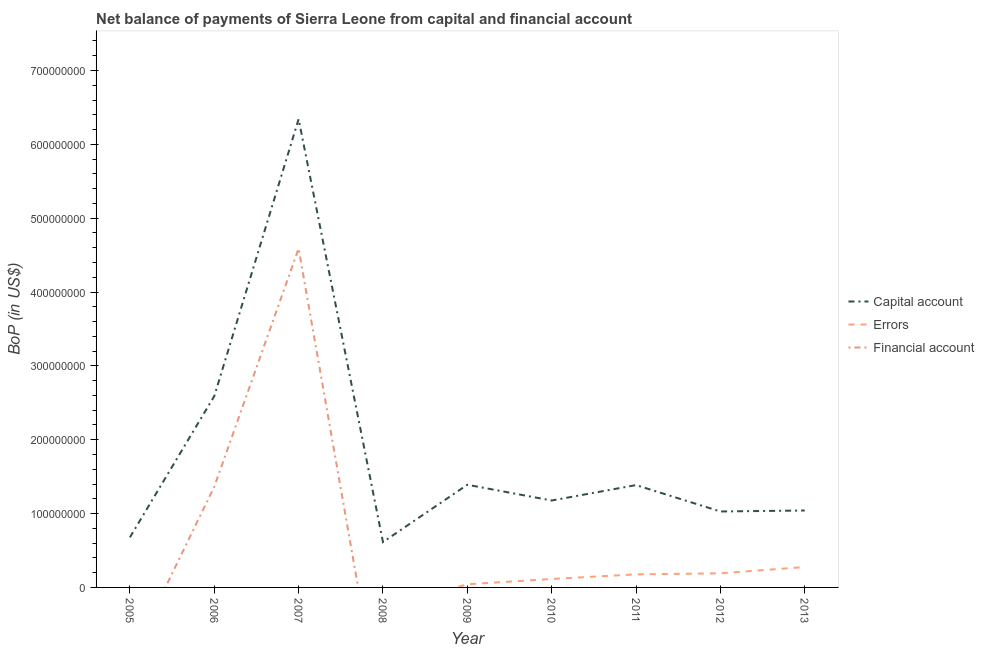What is the amount of net capital account in 2010?
Give a very brief answer. 1.18e+08. Across all years, what is the maximum amount of errors?
Offer a very short reply. 2.76e+07. Across all years, what is the minimum amount of financial account?
Your answer should be compact. 0. What is the total amount of errors in the graph?
Provide a succinct answer. 8.02e+07. What is the difference between the amount of errors in 2009 and that in 2013?
Offer a very short reply. -2.34e+07. What is the difference between the amount of errors in 2010 and the amount of net capital account in 2012?
Provide a short and direct response. -9.14e+07. What is the average amount of financial account per year?
Keep it short and to the point. 6.61e+07. In the year 2007, what is the difference between the amount of financial account and amount of net capital account?
Provide a succinct answer. -1.75e+08. In how many years, is the amount of net capital account greater than 280000000 US$?
Give a very brief answer. 1. What is the ratio of the amount of net capital account in 2008 to that in 2011?
Your answer should be very brief. 0.44. What is the difference between the highest and the second highest amount of errors?
Make the answer very short. 8.55e+06. What is the difference between the highest and the lowest amount of errors?
Provide a succinct answer. 2.76e+07. Is the sum of the amount of net capital account in 2008 and 2011 greater than the maximum amount of errors across all years?
Your answer should be very brief. Yes. Is it the case that in every year, the sum of the amount of net capital account and amount of errors is greater than the amount of financial account?
Offer a terse response. Yes. Does the amount of net capital account monotonically increase over the years?
Provide a succinct answer. No. How many years are there in the graph?
Your answer should be compact. 9. What is the difference between two consecutive major ticks on the Y-axis?
Provide a short and direct response. 1.00e+08. Are the values on the major ticks of Y-axis written in scientific E-notation?
Keep it short and to the point. No. Does the graph contain grids?
Make the answer very short. No. Where does the legend appear in the graph?
Offer a terse response. Center right. What is the title of the graph?
Your response must be concise. Net balance of payments of Sierra Leone from capital and financial account. Does "Natural gas sources" appear as one of the legend labels in the graph?
Make the answer very short. No. What is the label or title of the Y-axis?
Offer a terse response. BoP (in US$). What is the BoP (in US$) of Capital account in 2005?
Your response must be concise. 6.78e+07. What is the BoP (in US$) in Capital account in 2006?
Ensure brevity in your answer.  2.59e+08. What is the BoP (in US$) of Financial account in 2006?
Give a very brief answer. 1.36e+08. What is the BoP (in US$) of Capital account in 2007?
Your answer should be very brief. 6.34e+08. What is the BoP (in US$) of Errors in 2007?
Provide a succinct answer. 0. What is the BoP (in US$) of Financial account in 2007?
Keep it short and to the point. 4.59e+08. What is the BoP (in US$) of Capital account in 2008?
Keep it short and to the point. 6.14e+07. What is the BoP (in US$) of Errors in 2008?
Ensure brevity in your answer.  0. What is the BoP (in US$) of Capital account in 2009?
Offer a very short reply. 1.39e+08. What is the BoP (in US$) in Errors in 2009?
Keep it short and to the point. 4.23e+06. What is the BoP (in US$) of Capital account in 2010?
Offer a terse response. 1.18e+08. What is the BoP (in US$) in Errors in 2010?
Your answer should be compact. 1.15e+07. What is the BoP (in US$) of Capital account in 2011?
Provide a succinct answer. 1.39e+08. What is the BoP (in US$) of Errors in 2011?
Your answer should be compact. 1.77e+07. What is the BoP (in US$) of Capital account in 2012?
Provide a succinct answer. 1.03e+08. What is the BoP (in US$) of Errors in 2012?
Provide a succinct answer. 1.91e+07. What is the BoP (in US$) in Capital account in 2013?
Your response must be concise. 1.04e+08. What is the BoP (in US$) of Errors in 2013?
Offer a very short reply. 2.76e+07. Across all years, what is the maximum BoP (in US$) of Capital account?
Provide a succinct answer. 6.34e+08. Across all years, what is the maximum BoP (in US$) of Errors?
Offer a terse response. 2.76e+07. Across all years, what is the maximum BoP (in US$) of Financial account?
Your response must be concise. 4.59e+08. Across all years, what is the minimum BoP (in US$) of Capital account?
Provide a short and direct response. 6.14e+07. What is the total BoP (in US$) in Capital account in the graph?
Provide a short and direct response. 1.62e+09. What is the total BoP (in US$) in Errors in the graph?
Offer a very short reply. 8.02e+07. What is the total BoP (in US$) of Financial account in the graph?
Make the answer very short. 5.95e+08. What is the difference between the BoP (in US$) of Capital account in 2005 and that in 2006?
Offer a very short reply. -1.91e+08. What is the difference between the BoP (in US$) of Capital account in 2005 and that in 2007?
Your answer should be very brief. -5.66e+08. What is the difference between the BoP (in US$) of Capital account in 2005 and that in 2008?
Offer a terse response. 6.38e+06. What is the difference between the BoP (in US$) in Capital account in 2005 and that in 2009?
Ensure brevity in your answer.  -7.12e+07. What is the difference between the BoP (in US$) of Capital account in 2005 and that in 2010?
Your answer should be very brief. -4.99e+07. What is the difference between the BoP (in US$) of Capital account in 2005 and that in 2011?
Your answer should be compact. -7.08e+07. What is the difference between the BoP (in US$) in Capital account in 2005 and that in 2012?
Ensure brevity in your answer.  -3.51e+07. What is the difference between the BoP (in US$) of Capital account in 2005 and that in 2013?
Offer a very short reply. -3.64e+07. What is the difference between the BoP (in US$) in Capital account in 2006 and that in 2007?
Provide a short and direct response. -3.75e+08. What is the difference between the BoP (in US$) of Financial account in 2006 and that in 2007?
Ensure brevity in your answer.  -3.23e+08. What is the difference between the BoP (in US$) in Capital account in 2006 and that in 2008?
Make the answer very short. 1.98e+08. What is the difference between the BoP (in US$) in Capital account in 2006 and that in 2009?
Keep it short and to the point. 1.20e+08. What is the difference between the BoP (in US$) of Capital account in 2006 and that in 2010?
Provide a short and direct response. 1.41e+08. What is the difference between the BoP (in US$) of Capital account in 2006 and that in 2011?
Make the answer very short. 1.20e+08. What is the difference between the BoP (in US$) of Capital account in 2006 and that in 2012?
Your answer should be compact. 1.56e+08. What is the difference between the BoP (in US$) in Capital account in 2006 and that in 2013?
Your response must be concise. 1.55e+08. What is the difference between the BoP (in US$) of Capital account in 2007 and that in 2008?
Keep it short and to the point. 5.73e+08. What is the difference between the BoP (in US$) of Capital account in 2007 and that in 2009?
Your answer should be compact. 4.95e+08. What is the difference between the BoP (in US$) in Capital account in 2007 and that in 2010?
Make the answer very short. 5.16e+08. What is the difference between the BoP (in US$) of Capital account in 2007 and that in 2011?
Your answer should be very brief. 4.96e+08. What is the difference between the BoP (in US$) of Capital account in 2007 and that in 2012?
Give a very brief answer. 5.31e+08. What is the difference between the BoP (in US$) of Capital account in 2007 and that in 2013?
Offer a very short reply. 5.30e+08. What is the difference between the BoP (in US$) of Capital account in 2008 and that in 2009?
Offer a very short reply. -7.76e+07. What is the difference between the BoP (in US$) of Capital account in 2008 and that in 2010?
Your answer should be very brief. -5.63e+07. What is the difference between the BoP (in US$) in Capital account in 2008 and that in 2011?
Give a very brief answer. -7.72e+07. What is the difference between the BoP (in US$) in Capital account in 2008 and that in 2012?
Keep it short and to the point. -4.14e+07. What is the difference between the BoP (in US$) of Capital account in 2008 and that in 2013?
Provide a short and direct response. -4.27e+07. What is the difference between the BoP (in US$) of Capital account in 2009 and that in 2010?
Offer a very short reply. 2.13e+07. What is the difference between the BoP (in US$) of Errors in 2009 and that in 2010?
Keep it short and to the point. -7.24e+06. What is the difference between the BoP (in US$) of Capital account in 2009 and that in 2011?
Your answer should be very brief. 4.53e+05. What is the difference between the BoP (in US$) in Errors in 2009 and that in 2011?
Provide a succinct answer. -1.35e+07. What is the difference between the BoP (in US$) of Capital account in 2009 and that in 2012?
Offer a very short reply. 3.62e+07. What is the difference between the BoP (in US$) of Errors in 2009 and that in 2012?
Give a very brief answer. -1.49e+07. What is the difference between the BoP (in US$) in Capital account in 2009 and that in 2013?
Offer a terse response. 3.49e+07. What is the difference between the BoP (in US$) of Errors in 2009 and that in 2013?
Provide a short and direct response. -2.34e+07. What is the difference between the BoP (in US$) of Capital account in 2010 and that in 2011?
Your answer should be compact. -2.09e+07. What is the difference between the BoP (in US$) of Errors in 2010 and that in 2011?
Ensure brevity in your answer.  -6.23e+06. What is the difference between the BoP (in US$) of Capital account in 2010 and that in 2012?
Your answer should be compact. 1.48e+07. What is the difference between the BoP (in US$) in Errors in 2010 and that in 2012?
Offer a very short reply. -7.62e+06. What is the difference between the BoP (in US$) of Capital account in 2010 and that in 2013?
Your answer should be compact. 1.35e+07. What is the difference between the BoP (in US$) in Errors in 2010 and that in 2013?
Your answer should be very brief. -1.62e+07. What is the difference between the BoP (in US$) in Capital account in 2011 and that in 2012?
Offer a very short reply. 3.57e+07. What is the difference between the BoP (in US$) in Errors in 2011 and that in 2012?
Give a very brief answer. -1.39e+06. What is the difference between the BoP (in US$) of Capital account in 2011 and that in 2013?
Your answer should be compact. 3.44e+07. What is the difference between the BoP (in US$) in Errors in 2011 and that in 2013?
Your answer should be very brief. -9.94e+06. What is the difference between the BoP (in US$) of Capital account in 2012 and that in 2013?
Give a very brief answer. -1.31e+06. What is the difference between the BoP (in US$) in Errors in 2012 and that in 2013?
Give a very brief answer. -8.55e+06. What is the difference between the BoP (in US$) in Capital account in 2005 and the BoP (in US$) in Financial account in 2006?
Make the answer very short. -6.86e+07. What is the difference between the BoP (in US$) in Capital account in 2005 and the BoP (in US$) in Financial account in 2007?
Offer a very short reply. -3.91e+08. What is the difference between the BoP (in US$) of Capital account in 2005 and the BoP (in US$) of Errors in 2009?
Your answer should be compact. 6.36e+07. What is the difference between the BoP (in US$) of Capital account in 2005 and the BoP (in US$) of Errors in 2010?
Your response must be concise. 5.63e+07. What is the difference between the BoP (in US$) of Capital account in 2005 and the BoP (in US$) of Errors in 2011?
Offer a very short reply. 5.01e+07. What is the difference between the BoP (in US$) of Capital account in 2005 and the BoP (in US$) of Errors in 2012?
Provide a succinct answer. 4.87e+07. What is the difference between the BoP (in US$) of Capital account in 2005 and the BoP (in US$) of Errors in 2013?
Provide a short and direct response. 4.02e+07. What is the difference between the BoP (in US$) in Capital account in 2006 and the BoP (in US$) in Financial account in 2007?
Give a very brief answer. -2.00e+08. What is the difference between the BoP (in US$) in Capital account in 2006 and the BoP (in US$) in Errors in 2009?
Your response must be concise. 2.55e+08. What is the difference between the BoP (in US$) of Capital account in 2006 and the BoP (in US$) of Errors in 2010?
Keep it short and to the point. 2.48e+08. What is the difference between the BoP (in US$) in Capital account in 2006 and the BoP (in US$) in Errors in 2011?
Your response must be concise. 2.41e+08. What is the difference between the BoP (in US$) in Capital account in 2006 and the BoP (in US$) in Errors in 2012?
Make the answer very short. 2.40e+08. What is the difference between the BoP (in US$) in Capital account in 2006 and the BoP (in US$) in Errors in 2013?
Offer a very short reply. 2.31e+08. What is the difference between the BoP (in US$) in Capital account in 2007 and the BoP (in US$) in Errors in 2009?
Provide a short and direct response. 6.30e+08. What is the difference between the BoP (in US$) in Capital account in 2007 and the BoP (in US$) in Errors in 2010?
Your response must be concise. 6.23e+08. What is the difference between the BoP (in US$) in Capital account in 2007 and the BoP (in US$) in Errors in 2011?
Offer a very short reply. 6.16e+08. What is the difference between the BoP (in US$) of Capital account in 2007 and the BoP (in US$) of Errors in 2012?
Provide a short and direct response. 6.15e+08. What is the difference between the BoP (in US$) in Capital account in 2007 and the BoP (in US$) in Errors in 2013?
Keep it short and to the point. 6.07e+08. What is the difference between the BoP (in US$) in Capital account in 2008 and the BoP (in US$) in Errors in 2009?
Provide a short and direct response. 5.72e+07. What is the difference between the BoP (in US$) in Capital account in 2008 and the BoP (in US$) in Errors in 2010?
Offer a terse response. 5.00e+07. What is the difference between the BoP (in US$) in Capital account in 2008 and the BoP (in US$) in Errors in 2011?
Your response must be concise. 4.37e+07. What is the difference between the BoP (in US$) of Capital account in 2008 and the BoP (in US$) of Errors in 2012?
Your response must be concise. 4.23e+07. What is the difference between the BoP (in US$) in Capital account in 2008 and the BoP (in US$) in Errors in 2013?
Offer a terse response. 3.38e+07. What is the difference between the BoP (in US$) of Capital account in 2009 and the BoP (in US$) of Errors in 2010?
Ensure brevity in your answer.  1.28e+08. What is the difference between the BoP (in US$) in Capital account in 2009 and the BoP (in US$) in Errors in 2011?
Keep it short and to the point. 1.21e+08. What is the difference between the BoP (in US$) in Capital account in 2009 and the BoP (in US$) in Errors in 2012?
Your answer should be very brief. 1.20e+08. What is the difference between the BoP (in US$) in Capital account in 2009 and the BoP (in US$) in Errors in 2013?
Keep it short and to the point. 1.11e+08. What is the difference between the BoP (in US$) of Capital account in 2010 and the BoP (in US$) of Errors in 2011?
Offer a terse response. 1.00e+08. What is the difference between the BoP (in US$) in Capital account in 2010 and the BoP (in US$) in Errors in 2012?
Keep it short and to the point. 9.86e+07. What is the difference between the BoP (in US$) of Capital account in 2010 and the BoP (in US$) of Errors in 2013?
Provide a short and direct response. 9.01e+07. What is the difference between the BoP (in US$) of Capital account in 2011 and the BoP (in US$) of Errors in 2012?
Ensure brevity in your answer.  1.19e+08. What is the difference between the BoP (in US$) in Capital account in 2011 and the BoP (in US$) in Errors in 2013?
Ensure brevity in your answer.  1.11e+08. What is the difference between the BoP (in US$) of Capital account in 2012 and the BoP (in US$) of Errors in 2013?
Keep it short and to the point. 7.52e+07. What is the average BoP (in US$) in Capital account per year?
Keep it short and to the point. 1.81e+08. What is the average BoP (in US$) of Errors per year?
Offer a very short reply. 8.91e+06. What is the average BoP (in US$) of Financial account per year?
Offer a terse response. 6.61e+07. In the year 2006, what is the difference between the BoP (in US$) in Capital account and BoP (in US$) in Financial account?
Ensure brevity in your answer.  1.23e+08. In the year 2007, what is the difference between the BoP (in US$) of Capital account and BoP (in US$) of Financial account?
Your response must be concise. 1.75e+08. In the year 2009, what is the difference between the BoP (in US$) of Capital account and BoP (in US$) of Errors?
Your answer should be compact. 1.35e+08. In the year 2010, what is the difference between the BoP (in US$) in Capital account and BoP (in US$) in Errors?
Your response must be concise. 1.06e+08. In the year 2011, what is the difference between the BoP (in US$) in Capital account and BoP (in US$) in Errors?
Your answer should be very brief. 1.21e+08. In the year 2012, what is the difference between the BoP (in US$) in Capital account and BoP (in US$) in Errors?
Keep it short and to the point. 8.38e+07. In the year 2013, what is the difference between the BoP (in US$) in Capital account and BoP (in US$) in Errors?
Provide a short and direct response. 7.65e+07. What is the ratio of the BoP (in US$) in Capital account in 2005 to that in 2006?
Provide a succinct answer. 0.26. What is the ratio of the BoP (in US$) in Capital account in 2005 to that in 2007?
Your response must be concise. 0.11. What is the ratio of the BoP (in US$) of Capital account in 2005 to that in 2008?
Offer a terse response. 1.1. What is the ratio of the BoP (in US$) in Capital account in 2005 to that in 2009?
Provide a short and direct response. 0.49. What is the ratio of the BoP (in US$) in Capital account in 2005 to that in 2010?
Give a very brief answer. 0.58. What is the ratio of the BoP (in US$) of Capital account in 2005 to that in 2011?
Your answer should be very brief. 0.49. What is the ratio of the BoP (in US$) of Capital account in 2005 to that in 2012?
Ensure brevity in your answer.  0.66. What is the ratio of the BoP (in US$) in Capital account in 2005 to that in 2013?
Ensure brevity in your answer.  0.65. What is the ratio of the BoP (in US$) in Capital account in 2006 to that in 2007?
Give a very brief answer. 0.41. What is the ratio of the BoP (in US$) of Financial account in 2006 to that in 2007?
Offer a terse response. 0.3. What is the ratio of the BoP (in US$) in Capital account in 2006 to that in 2008?
Give a very brief answer. 4.22. What is the ratio of the BoP (in US$) in Capital account in 2006 to that in 2009?
Your answer should be very brief. 1.86. What is the ratio of the BoP (in US$) of Capital account in 2006 to that in 2010?
Provide a short and direct response. 2.2. What is the ratio of the BoP (in US$) of Capital account in 2006 to that in 2011?
Ensure brevity in your answer.  1.87. What is the ratio of the BoP (in US$) in Capital account in 2006 to that in 2012?
Your response must be concise. 2.52. What is the ratio of the BoP (in US$) in Capital account in 2006 to that in 2013?
Make the answer very short. 2.49. What is the ratio of the BoP (in US$) of Capital account in 2007 to that in 2008?
Offer a very short reply. 10.32. What is the ratio of the BoP (in US$) of Capital account in 2007 to that in 2009?
Offer a very short reply. 4.56. What is the ratio of the BoP (in US$) in Capital account in 2007 to that in 2010?
Ensure brevity in your answer.  5.39. What is the ratio of the BoP (in US$) in Capital account in 2007 to that in 2011?
Your answer should be very brief. 4.58. What is the ratio of the BoP (in US$) of Capital account in 2007 to that in 2012?
Keep it short and to the point. 6.17. What is the ratio of the BoP (in US$) of Capital account in 2007 to that in 2013?
Your answer should be very brief. 6.09. What is the ratio of the BoP (in US$) in Capital account in 2008 to that in 2009?
Offer a terse response. 0.44. What is the ratio of the BoP (in US$) in Capital account in 2008 to that in 2010?
Give a very brief answer. 0.52. What is the ratio of the BoP (in US$) in Capital account in 2008 to that in 2011?
Give a very brief answer. 0.44. What is the ratio of the BoP (in US$) in Capital account in 2008 to that in 2012?
Provide a succinct answer. 0.6. What is the ratio of the BoP (in US$) in Capital account in 2008 to that in 2013?
Offer a terse response. 0.59. What is the ratio of the BoP (in US$) in Capital account in 2009 to that in 2010?
Your answer should be very brief. 1.18. What is the ratio of the BoP (in US$) in Errors in 2009 to that in 2010?
Your answer should be compact. 0.37. What is the ratio of the BoP (in US$) of Capital account in 2009 to that in 2011?
Provide a short and direct response. 1. What is the ratio of the BoP (in US$) in Errors in 2009 to that in 2011?
Offer a terse response. 0.24. What is the ratio of the BoP (in US$) in Capital account in 2009 to that in 2012?
Provide a short and direct response. 1.35. What is the ratio of the BoP (in US$) in Errors in 2009 to that in 2012?
Keep it short and to the point. 0.22. What is the ratio of the BoP (in US$) of Capital account in 2009 to that in 2013?
Your answer should be very brief. 1.33. What is the ratio of the BoP (in US$) of Errors in 2009 to that in 2013?
Offer a very short reply. 0.15. What is the ratio of the BoP (in US$) in Capital account in 2010 to that in 2011?
Your answer should be compact. 0.85. What is the ratio of the BoP (in US$) in Errors in 2010 to that in 2011?
Provide a succinct answer. 0.65. What is the ratio of the BoP (in US$) in Capital account in 2010 to that in 2012?
Provide a succinct answer. 1.14. What is the ratio of the BoP (in US$) of Errors in 2010 to that in 2012?
Ensure brevity in your answer.  0.6. What is the ratio of the BoP (in US$) of Capital account in 2010 to that in 2013?
Offer a very short reply. 1.13. What is the ratio of the BoP (in US$) in Errors in 2010 to that in 2013?
Offer a very short reply. 0.42. What is the ratio of the BoP (in US$) in Capital account in 2011 to that in 2012?
Provide a short and direct response. 1.35. What is the ratio of the BoP (in US$) of Errors in 2011 to that in 2012?
Provide a short and direct response. 0.93. What is the ratio of the BoP (in US$) of Capital account in 2011 to that in 2013?
Your answer should be very brief. 1.33. What is the ratio of the BoP (in US$) of Errors in 2011 to that in 2013?
Your answer should be compact. 0.64. What is the ratio of the BoP (in US$) in Capital account in 2012 to that in 2013?
Your answer should be compact. 0.99. What is the ratio of the BoP (in US$) in Errors in 2012 to that in 2013?
Your answer should be compact. 0.69. What is the difference between the highest and the second highest BoP (in US$) of Capital account?
Provide a succinct answer. 3.75e+08. What is the difference between the highest and the second highest BoP (in US$) in Errors?
Keep it short and to the point. 8.55e+06. What is the difference between the highest and the lowest BoP (in US$) of Capital account?
Provide a succinct answer. 5.73e+08. What is the difference between the highest and the lowest BoP (in US$) in Errors?
Your response must be concise. 2.76e+07. What is the difference between the highest and the lowest BoP (in US$) in Financial account?
Offer a very short reply. 4.59e+08. 